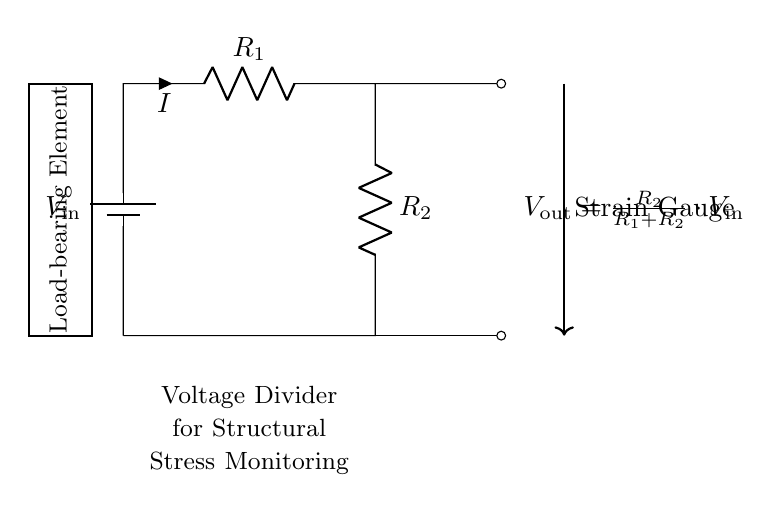What is the input voltage labeled in the circuit? The circuit diagram labels the input voltage as V_in, which is the supply voltage for the voltage divider.
Answer: V_in What is the formula for V_out in the circuit? The circuit diagram provides a formula for the output voltage, V_out, indicated as V_out = (R_2 / (R_1 + R_2)) * V_in. This shows how V_out is calculated based on the resistances and the input voltage.
Answer: V_out = R_2 / (R_1 + R_2) * V_in How many resistors are in the voltage divider circuit? The circuit diagram clearly shows two resistors (R_1 and R_2) connected in series, which are essential for the functioning of a voltage divider.
Answer: 2 What does the strain gauge represent in this circuit? The strain gauge is indicated by an arrow connected to the output, suggesting it is a sensor that measures the output voltage related to stress in the load-bearing element.
Answer: Sensor What happens to V_out when R_2 increases? Increasing R_2 while keeping R_1 constant increases the ratio R_2 / (R_1 + R_2), which in turn raises V_out, as indicated by the voltage divider principle.
Answer: V_out increases What type of circuit is this? The circuit shown is specifically a voltage divider configuration, commonly used for monitoring and measuring voltages in various applications, including structural monitoring.
Answer: Voltage divider 